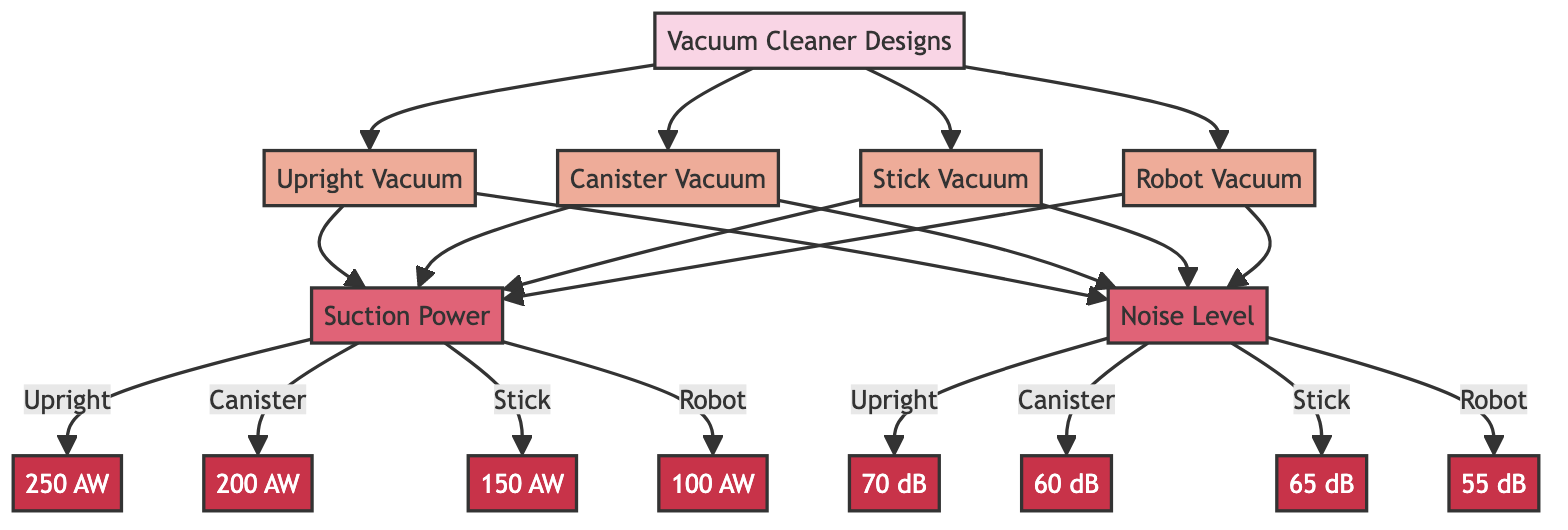What are the noise levels for the upright vacuum? The diagram indicates that the noise level (NL) for the upright vacuum (UV) is 70 dB. This information is displayed directly from the NL relationship with UV in the diagram.
Answer: 70 dB What is the suction power of the canister vacuum? The diagram shows that the suction power (SP) for the canister vacuum (CV) is 200 AW. This is derived from the SP relationship specifically stated for CV in the diagram.
Answer: 200 AW Which vacuum cleaner design has the highest noise level? By comparing the noise levels provided for each vacuum cleaner design, the upright vacuum (UV), canister vacuum (CV), stick vacuum (SV), and robot vacuum (RV) have noise levels of 70 dB, 60 dB, 65 dB, and 55 dB respectively. The highest value among these is 70 dB for the upright vacuum (UV).
Answer: Upright Vacuum What is the relationship between suction power and noise level in the robot vacuum? The diagram shows that for the robot vacuum (RV), the suction power (SP) is 100 AW and the noise level (NL) is 55 dB. Hence, the relationship indicates that the robot vacuum has both its respective SP and NL values connected in the diagram.
Answer: 100 AW, 55 dB How many vacuum cleaner designs are represented in the diagram? The diagram lists four specific vacuum cleaner designs: upright, canister, stick, and robot. Therefore, upon counting these designs, we find a total of 4 distinct vacuum cleaner designs represented in the diagram.
Answer: 4 What is the suction power-to-noise level ratio for the stick vacuum? For the stick vacuum (SV), the suction power is 150 AW and the noise level is 65 dB. The ratio of suction power to noise level can therefore be computed as 150 AW / 65 dB, which simplifies to approximately 2.31 (noting that this is a derived value based on the values shown in the diagram).
Answer: 2.31 Which vacuum cleaner design has the lowest suction power? Upon reviewing the suction power values provided in the diagram for each design, the values are 250 AW for upright, 200 AW for canister, 150 AW for stick, and 100 AW for robot. The lowest suction power among these is for the robot vacuum (RV), which has a suction power of 100 AW.
Answer: Robot Vacuum 